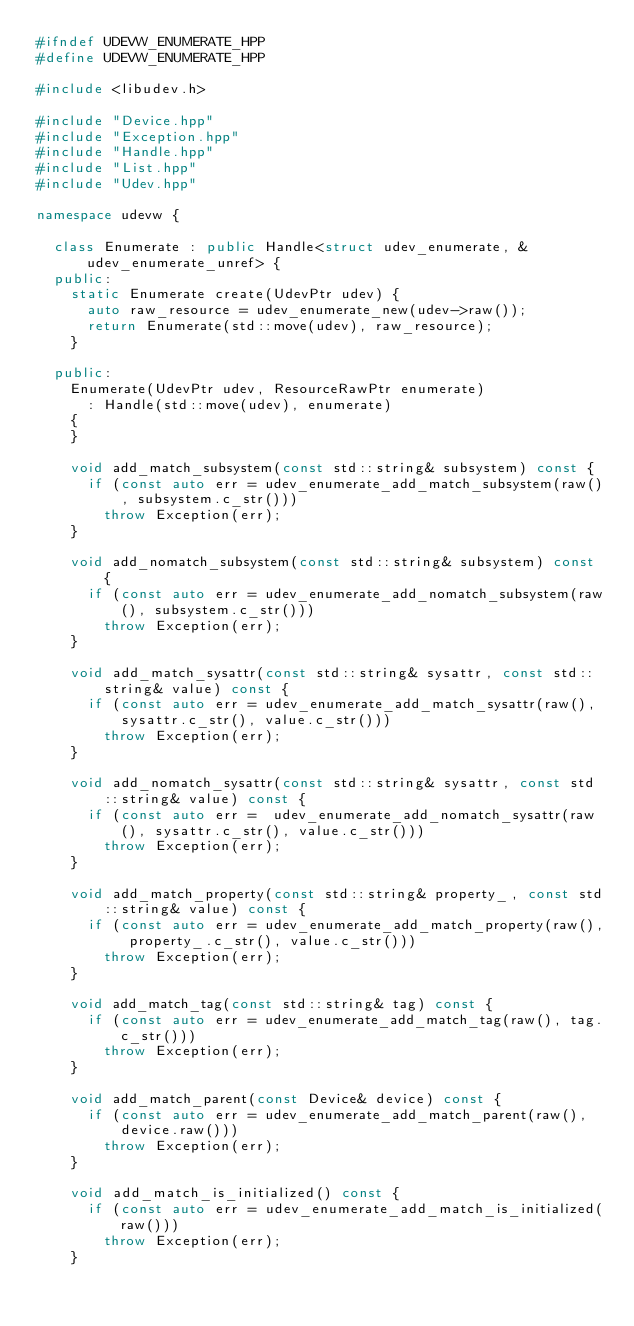<code> <loc_0><loc_0><loc_500><loc_500><_C++_>#ifndef UDEVW_ENUMERATE_HPP
#define UDEVW_ENUMERATE_HPP

#include <libudev.h>

#include "Device.hpp"
#include "Exception.hpp"
#include "Handle.hpp"
#include "List.hpp"
#include "Udev.hpp"

namespace udevw {

  class Enumerate : public Handle<struct udev_enumerate, &udev_enumerate_unref> {
  public:
    static Enumerate create(UdevPtr udev) {
      auto raw_resource = udev_enumerate_new(udev->raw());
      return Enumerate(std::move(udev), raw_resource);
    }

  public:
    Enumerate(UdevPtr udev, ResourceRawPtr enumerate)
      : Handle(std::move(udev), enumerate)
    {
    }

    void add_match_subsystem(const std::string& subsystem) const {
      if (const auto err = udev_enumerate_add_match_subsystem(raw(), subsystem.c_str()))
        throw Exception(err);
    }

    void add_nomatch_subsystem(const std::string& subsystem) const {
      if (const auto err = udev_enumerate_add_nomatch_subsystem(raw(), subsystem.c_str()))
        throw Exception(err);
    }

    void add_match_sysattr(const std::string& sysattr, const std::string& value) const {
      if (const auto err = udev_enumerate_add_match_sysattr(raw(), sysattr.c_str(), value.c_str()))
        throw Exception(err);
    }

    void add_nomatch_sysattr(const std::string& sysattr, const std::string& value) const {
      if (const auto err =  udev_enumerate_add_nomatch_sysattr(raw(), sysattr.c_str(), value.c_str()))
        throw Exception(err);
    }

    void add_match_property(const std::string& property_, const std::string& value) const {
      if (const auto err = udev_enumerate_add_match_property(raw(), property_.c_str(), value.c_str()))
        throw Exception(err);
    }

    void add_match_tag(const std::string& tag) const {
      if (const auto err = udev_enumerate_add_match_tag(raw(), tag.c_str()))
        throw Exception(err);
    }

    void add_match_parent(const Device& device) const {
      if (const auto err = udev_enumerate_add_match_parent(raw(), device.raw()))
        throw Exception(err);
    }

    void add_match_is_initialized() const {
      if (const auto err = udev_enumerate_add_match_is_initialized(raw()))
        throw Exception(err);
    }
</code> 